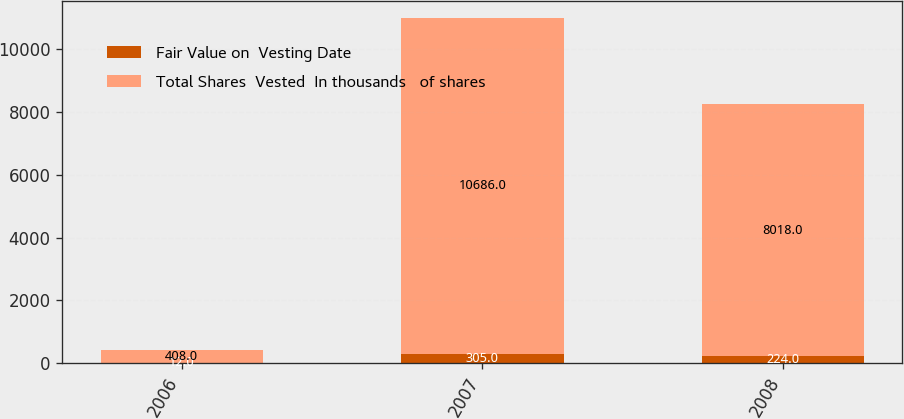<chart> <loc_0><loc_0><loc_500><loc_500><stacked_bar_chart><ecel><fcel>2006<fcel>2007<fcel>2008<nl><fcel>Fair Value on  Vesting Date<fcel>12<fcel>305<fcel>224<nl><fcel>Total Shares  Vested  In thousands   of shares<fcel>408<fcel>10686<fcel>8018<nl></chart> 